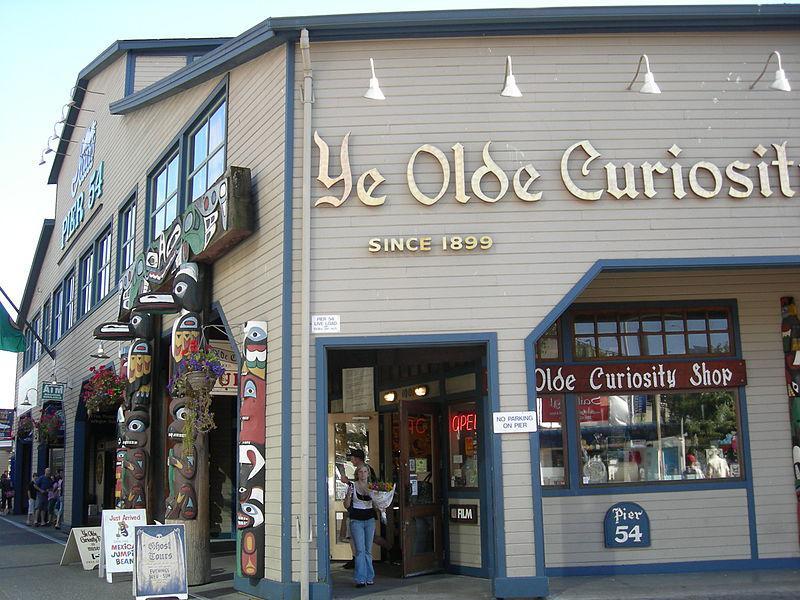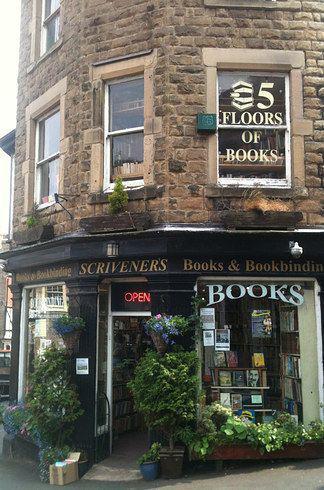The first image is the image on the left, the second image is the image on the right. Assess this claim about the two images: "To the left of the build there is at least one folding sign advertising the shop.". Correct or not? Answer yes or no. Yes. 